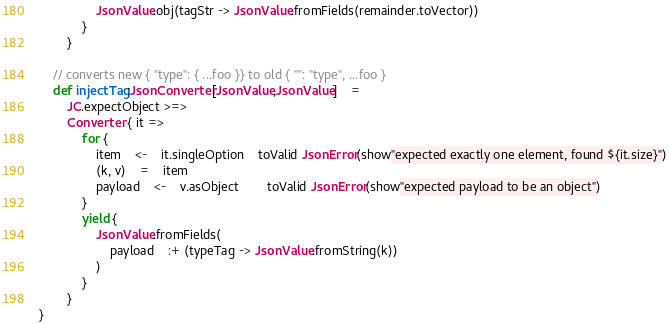Convert code to text. <code><loc_0><loc_0><loc_500><loc_500><_Scala_>				JsonValue.obj(tagStr -> JsonValue.fromFields(remainder.toVector))
			}
		}

	// converts new { "type": { ...foo }} to old { "": "type", ...foo }
	def injectTag:JsonConverter[JsonValue,JsonValue]	=
		JC.expectObject >=>
		Converter { it =>
			for {
				item	<-	it.singleOption	toValid JsonError(show"expected exactly one element, found ${it.size}")
				(k, v)	=	item
				payload	<-	v.asObject		toValid JsonError(show"expected payload to be an object")
			}
			yield {
				JsonValue.fromFields(
					payload	:+ (typeTag -> JsonValue.fromString(k))
				)
			}
		}
}
</code> 